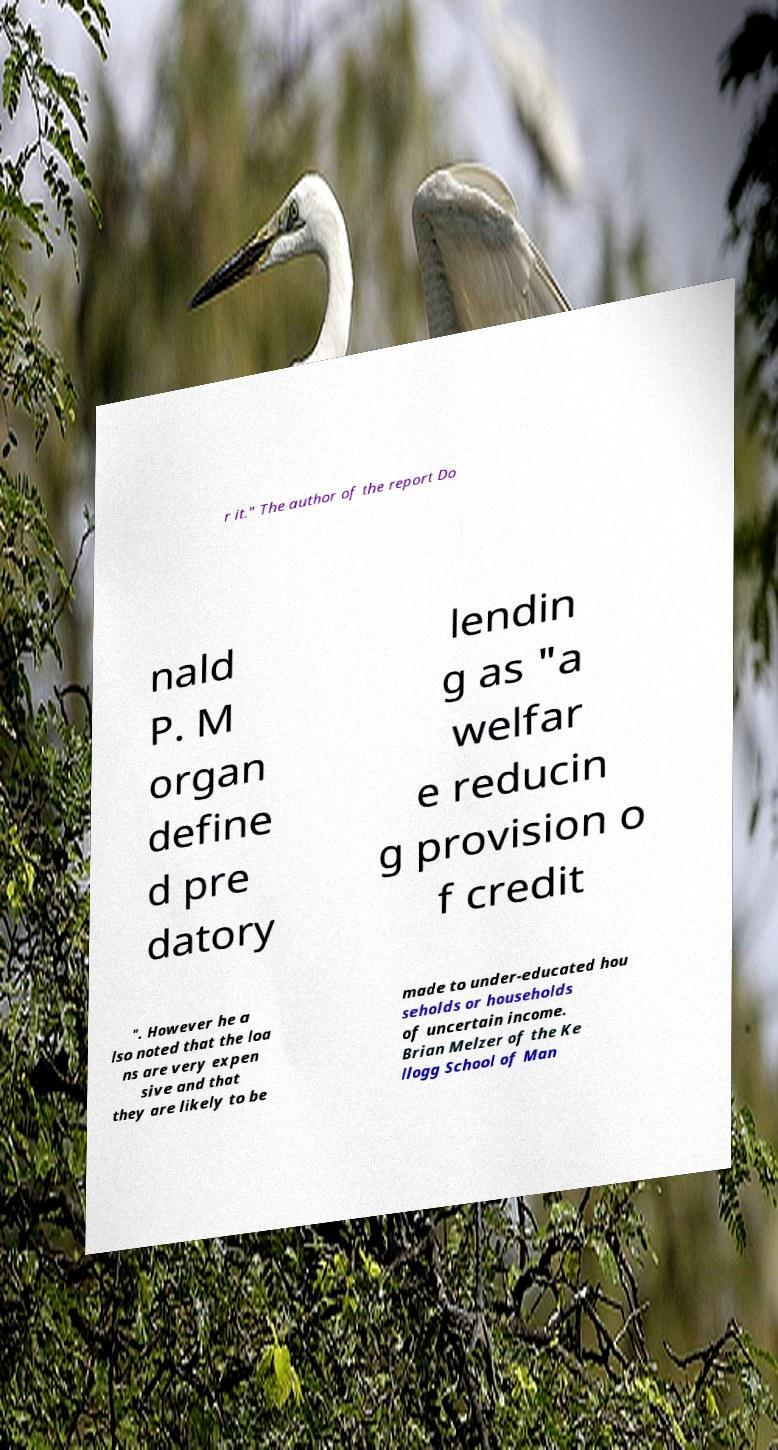Could you assist in decoding the text presented in this image and type it out clearly? r it." The author of the report Do nald P. M organ define d pre datory lendin g as "a welfar e reducin g provision o f credit ". However he a lso noted that the loa ns are very expen sive and that they are likely to be made to under-educated hou seholds or households of uncertain income. Brian Melzer of the Ke llogg School of Man 